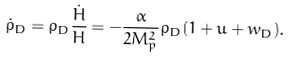Convert formula to latex. <formula><loc_0><loc_0><loc_500><loc_500>\dot { \rho } _ { D } = \rho _ { D } \frac { \dot { H } } { H } = - \frac { \alpha } { 2 M _ { p } ^ { 2 } } \rho _ { D } ( 1 + u + w _ { D } ) .</formula> 